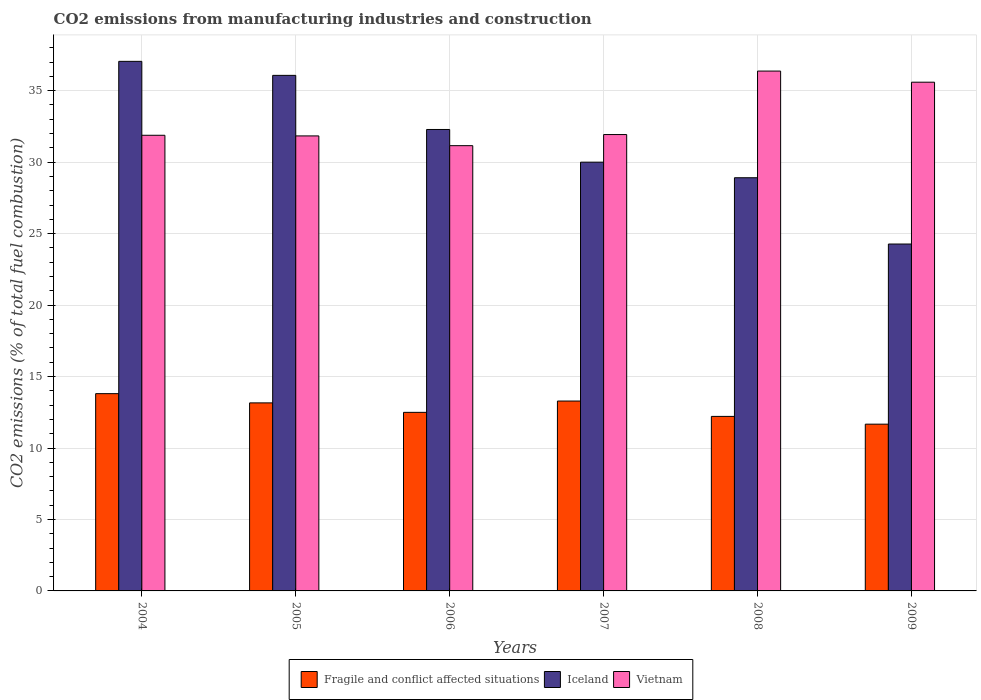Are the number of bars per tick equal to the number of legend labels?
Provide a succinct answer. Yes. Are the number of bars on each tick of the X-axis equal?
Provide a succinct answer. Yes. In how many cases, is the number of bars for a given year not equal to the number of legend labels?
Provide a succinct answer. 0. What is the amount of CO2 emitted in Iceland in 2008?
Your response must be concise. 28.91. Across all years, what is the maximum amount of CO2 emitted in Fragile and conflict affected situations?
Keep it short and to the point. 13.8. Across all years, what is the minimum amount of CO2 emitted in Fragile and conflict affected situations?
Offer a terse response. 11.67. What is the total amount of CO2 emitted in Vietnam in the graph?
Your answer should be very brief. 198.77. What is the difference between the amount of CO2 emitted in Vietnam in 2006 and that in 2008?
Offer a terse response. -5.22. What is the difference between the amount of CO2 emitted in Iceland in 2006 and the amount of CO2 emitted in Fragile and conflict affected situations in 2004?
Offer a terse response. 18.48. What is the average amount of CO2 emitted in Vietnam per year?
Your response must be concise. 33.13. In the year 2004, what is the difference between the amount of CO2 emitted in Iceland and amount of CO2 emitted in Fragile and conflict affected situations?
Give a very brief answer. 23.25. What is the ratio of the amount of CO2 emitted in Iceland in 2004 to that in 2007?
Provide a short and direct response. 1.24. Is the amount of CO2 emitted in Iceland in 2004 less than that in 2009?
Your answer should be compact. No. What is the difference between the highest and the second highest amount of CO2 emitted in Fragile and conflict affected situations?
Your response must be concise. 0.52. What is the difference between the highest and the lowest amount of CO2 emitted in Fragile and conflict affected situations?
Give a very brief answer. 2.13. In how many years, is the amount of CO2 emitted in Vietnam greater than the average amount of CO2 emitted in Vietnam taken over all years?
Keep it short and to the point. 2. What does the 3rd bar from the left in 2007 represents?
Your answer should be compact. Vietnam. What does the 3rd bar from the right in 2009 represents?
Ensure brevity in your answer.  Fragile and conflict affected situations. Is it the case that in every year, the sum of the amount of CO2 emitted in Vietnam and amount of CO2 emitted in Iceland is greater than the amount of CO2 emitted in Fragile and conflict affected situations?
Offer a terse response. Yes. Are the values on the major ticks of Y-axis written in scientific E-notation?
Your response must be concise. No. Does the graph contain any zero values?
Your answer should be compact. No. Does the graph contain grids?
Ensure brevity in your answer.  Yes. How many legend labels are there?
Your answer should be compact. 3. What is the title of the graph?
Your answer should be very brief. CO2 emissions from manufacturing industries and construction. Does "Kenya" appear as one of the legend labels in the graph?
Your answer should be very brief. No. What is the label or title of the Y-axis?
Your answer should be compact. CO2 emissions (% of total fuel combustion). What is the CO2 emissions (% of total fuel combustion) in Fragile and conflict affected situations in 2004?
Your answer should be very brief. 13.8. What is the CO2 emissions (% of total fuel combustion) in Iceland in 2004?
Your response must be concise. 37.05. What is the CO2 emissions (% of total fuel combustion) in Vietnam in 2004?
Make the answer very short. 31.88. What is the CO2 emissions (% of total fuel combustion) of Fragile and conflict affected situations in 2005?
Your answer should be compact. 13.16. What is the CO2 emissions (% of total fuel combustion) in Iceland in 2005?
Offer a very short reply. 36.07. What is the CO2 emissions (% of total fuel combustion) in Vietnam in 2005?
Provide a short and direct response. 31.84. What is the CO2 emissions (% of total fuel combustion) of Fragile and conflict affected situations in 2006?
Keep it short and to the point. 12.49. What is the CO2 emissions (% of total fuel combustion) in Iceland in 2006?
Make the answer very short. 32.29. What is the CO2 emissions (% of total fuel combustion) of Vietnam in 2006?
Offer a very short reply. 31.15. What is the CO2 emissions (% of total fuel combustion) in Fragile and conflict affected situations in 2007?
Offer a terse response. 13.29. What is the CO2 emissions (% of total fuel combustion) in Vietnam in 2007?
Offer a terse response. 31.93. What is the CO2 emissions (% of total fuel combustion) of Fragile and conflict affected situations in 2008?
Provide a short and direct response. 12.21. What is the CO2 emissions (% of total fuel combustion) of Iceland in 2008?
Keep it short and to the point. 28.91. What is the CO2 emissions (% of total fuel combustion) of Vietnam in 2008?
Ensure brevity in your answer.  36.37. What is the CO2 emissions (% of total fuel combustion) of Fragile and conflict affected situations in 2009?
Give a very brief answer. 11.67. What is the CO2 emissions (% of total fuel combustion) of Iceland in 2009?
Provide a short and direct response. 24.27. What is the CO2 emissions (% of total fuel combustion) of Vietnam in 2009?
Keep it short and to the point. 35.6. Across all years, what is the maximum CO2 emissions (% of total fuel combustion) of Fragile and conflict affected situations?
Your answer should be compact. 13.8. Across all years, what is the maximum CO2 emissions (% of total fuel combustion) of Iceland?
Ensure brevity in your answer.  37.05. Across all years, what is the maximum CO2 emissions (% of total fuel combustion) in Vietnam?
Offer a terse response. 36.37. Across all years, what is the minimum CO2 emissions (% of total fuel combustion) in Fragile and conflict affected situations?
Offer a very short reply. 11.67. Across all years, what is the minimum CO2 emissions (% of total fuel combustion) of Iceland?
Give a very brief answer. 24.27. Across all years, what is the minimum CO2 emissions (% of total fuel combustion) of Vietnam?
Ensure brevity in your answer.  31.15. What is the total CO2 emissions (% of total fuel combustion) in Fragile and conflict affected situations in the graph?
Provide a short and direct response. 76.62. What is the total CO2 emissions (% of total fuel combustion) of Iceland in the graph?
Keep it short and to the point. 188.6. What is the total CO2 emissions (% of total fuel combustion) of Vietnam in the graph?
Your response must be concise. 198.77. What is the difference between the CO2 emissions (% of total fuel combustion) in Fragile and conflict affected situations in 2004 and that in 2005?
Your answer should be compact. 0.65. What is the difference between the CO2 emissions (% of total fuel combustion) in Iceland in 2004 and that in 2005?
Offer a very short reply. 0.98. What is the difference between the CO2 emissions (% of total fuel combustion) in Vietnam in 2004 and that in 2005?
Ensure brevity in your answer.  0.04. What is the difference between the CO2 emissions (% of total fuel combustion) of Fragile and conflict affected situations in 2004 and that in 2006?
Keep it short and to the point. 1.31. What is the difference between the CO2 emissions (% of total fuel combustion) in Iceland in 2004 and that in 2006?
Ensure brevity in your answer.  4.77. What is the difference between the CO2 emissions (% of total fuel combustion) in Vietnam in 2004 and that in 2006?
Ensure brevity in your answer.  0.73. What is the difference between the CO2 emissions (% of total fuel combustion) of Fragile and conflict affected situations in 2004 and that in 2007?
Your answer should be very brief. 0.52. What is the difference between the CO2 emissions (% of total fuel combustion) of Iceland in 2004 and that in 2007?
Your response must be concise. 7.05. What is the difference between the CO2 emissions (% of total fuel combustion) of Vietnam in 2004 and that in 2007?
Keep it short and to the point. -0.05. What is the difference between the CO2 emissions (% of total fuel combustion) in Fragile and conflict affected situations in 2004 and that in 2008?
Offer a terse response. 1.59. What is the difference between the CO2 emissions (% of total fuel combustion) in Iceland in 2004 and that in 2008?
Your response must be concise. 8.14. What is the difference between the CO2 emissions (% of total fuel combustion) in Vietnam in 2004 and that in 2008?
Give a very brief answer. -4.49. What is the difference between the CO2 emissions (% of total fuel combustion) of Fragile and conflict affected situations in 2004 and that in 2009?
Keep it short and to the point. 2.13. What is the difference between the CO2 emissions (% of total fuel combustion) in Iceland in 2004 and that in 2009?
Your response must be concise. 12.78. What is the difference between the CO2 emissions (% of total fuel combustion) of Vietnam in 2004 and that in 2009?
Provide a short and direct response. -3.71. What is the difference between the CO2 emissions (% of total fuel combustion) in Fragile and conflict affected situations in 2005 and that in 2006?
Your answer should be very brief. 0.66. What is the difference between the CO2 emissions (% of total fuel combustion) of Iceland in 2005 and that in 2006?
Offer a very short reply. 3.79. What is the difference between the CO2 emissions (% of total fuel combustion) of Vietnam in 2005 and that in 2006?
Ensure brevity in your answer.  0.68. What is the difference between the CO2 emissions (% of total fuel combustion) in Fragile and conflict affected situations in 2005 and that in 2007?
Your answer should be compact. -0.13. What is the difference between the CO2 emissions (% of total fuel combustion) of Iceland in 2005 and that in 2007?
Your answer should be very brief. 6.07. What is the difference between the CO2 emissions (% of total fuel combustion) in Vietnam in 2005 and that in 2007?
Ensure brevity in your answer.  -0.09. What is the difference between the CO2 emissions (% of total fuel combustion) of Fragile and conflict affected situations in 2005 and that in 2008?
Provide a short and direct response. 0.95. What is the difference between the CO2 emissions (% of total fuel combustion) in Iceland in 2005 and that in 2008?
Your response must be concise. 7.16. What is the difference between the CO2 emissions (% of total fuel combustion) in Vietnam in 2005 and that in 2008?
Keep it short and to the point. -4.54. What is the difference between the CO2 emissions (% of total fuel combustion) of Fragile and conflict affected situations in 2005 and that in 2009?
Your answer should be very brief. 1.49. What is the difference between the CO2 emissions (% of total fuel combustion) in Iceland in 2005 and that in 2009?
Keep it short and to the point. 11.8. What is the difference between the CO2 emissions (% of total fuel combustion) of Vietnam in 2005 and that in 2009?
Provide a short and direct response. -3.76. What is the difference between the CO2 emissions (% of total fuel combustion) of Fragile and conflict affected situations in 2006 and that in 2007?
Your response must be concise. -0.79. What is the difference between the CO2 emissions (% of total fuel combustion) in Iceland in 2006 and that in 2007?
Keep it short and to the point. 2.29. What is the difference between the CO2 emissions (% of total fuel combustion) of Vietnam in 2006 and that in 2007?
Ensure brevity in your answer.  -0.78. What is the difference between the CO2 emissions (% of total fuel combustion) in Fragile and conflict affected situations in 2006 and that in 2008?
Provide a short and direct response. 0.28. What is the difference between the CO2 emissions (% of total fuel combustion) of Iceland in 2006 and that in 2008?
Provide a short and direct response. 3.38. What is the difference between the CO2 emissions (% of total fuel combustion) of Vietnam in 2006 and that in 2008?
Offer a very short reply. -5.22. What is the difference between the CO2 emissions (% of total fuel combustion) in Fragile and conflict affected situations in 2006 and that in 2009?
Make the answer very short. 0.83. What is the difference between the CO2 emissions (% of total fuel combustion) in Iceland in 2006 and that in 2009?
Give a very brief answer. 8.02. What is the difference between the CO2 emissions (% of total fuel combustion) of Vietnam in 2006 and that in 2009?
Ensure brevity in your answer.  -4.44. What is the difference between the CO2 emissions (% of total fuel combustion) in Fragile and conflict affected situations in 2007 and that in 2008?
Provide a short and direct response. 1.07. What is the difference between the CO2 emissions (% of total fuel combustion) of Iceland in 2007 and that in 2008?
Provide a succinct answer. 1.09. What is the difference between the CO2 emissions (% of total fuel combustion) of Vietnam in 2007 and that in 2008?
Give a very brief answer. -4.44. What is the difference between the CO2 emissions (% of total fuel combustion) in Fragile and conflict affected situations in 2007 and that in 2009?
Your answer should be very brief. 1.62. What is the difference between the CO2 emissions (% of total fuel combustion) of Iceland in 2007 and that in 2009?
Provide a short and direct response. 5.73. What is the difference between the CO2 emissions (% of total fuel combustion) of Vietnam in 2007 and that in 2009?
Your answer should be compact. -3.66. What is the difference between the CO2 emissions (% of total fuel combustion) of Fragile and conflict affected situations in 2008 and that in 2009?
Offer a very short reply. 0.54. What is the difference between the CO2 emissions (% of total fuel combustion) of Iceland in 2008 and that in 2009?
Provide a short and direct response. 4.64. What is the difference between the CO2 emissions (% of total fuel combustion) of Vietnam in 2008 and that in 2009?
Provide a short and direct response. 0.78. What is the difference between the CO2 emissions (% of total fuel combustion) of Fragile and conflict affected situations in 2004 and the CO2 emissions (% of total fuel combustion) of Iceland in 2005?
Your answer should be very brief. -22.27. What is the difference between the CO2 emissions (% of total fuel combustion) in Fragile and conflict affected situations in 2004 and the CO2 emissions (% of total fuel combustion) in Vietnam in 2005?
Your answer should be very brief. -18.03. What is the difference between the CO2 emissions (% of total fuel combustion) of Iceland in 2004 and the CO2 emissions (% of total fuel combustion) of Vietnam in 2005?
Ensure brevity in your answer.  5.22. What is the difference between the CO2 emissions (% of total fuel combustion) of Fragile and conflict affected situations in 2004 and the CO2 emissions (% of total fuel combustion) of Iceland in 2006?
Make the answer very short. -18.48. What is the difference between the CO2 emissions (% of total fuel combustion) of Fragile and conflict affected situations in 2004 and the CO2 emissions (% of total fuel combustion) of Vietnam in 2006?
Give a very brief answer. -17.35. What is the difference between the CO2 emissions (% of total fuel combustion) in Iceland in 2004 and the CO2 emissions (% of total fuel combustion) in Vietnam in 2006?
Your response must be concise. 5.9. What is the difference between the CO2 emissions (% of total fuel combustion) in Fragile and conflict affected situations in 2004 and the CO2 emissions (% of total fuel combustion) in Iceland in 2007?
Your answer should be very brief. -16.2. What is the difference between the CO2 emissions (% of total fuel combustion) of Fragile and conflict affected situations in 2004 and the CO2 emissions (% of total fuel combustion) of Vietnam in 2007?
Offer a very short reply. -18.13. What is the difference between the CO2 emissions (% of total fuel combustion) of Iceland in 2004 and the CO2 emissions (% of total fuel combustion) of Vietnam in 2007?
Give a very brief answer. 5.12. What is the difference between the CO2 emissions (% of total fuel combustion) in Fragile and conflict affected situations in 2004 and the CO2 emissions (% of total fuel combustion) in Iceland in 2008?
Your answer should be very brief. -15.11. What is the difference between the CO2 emissions (% of total fuel combustion) in Fragile and conflict affected situations in 2004 and the CO2 emissions (% of total fuel combustion) in Vietnam in 2008?
Your response must be concise. -22.57. What is the difference between the CO2 emissions (% of total fuel combustion) in Iceland in 2004 and the CO2 emissions (% of total fuel combustion) in Vietnam in 2008?
Your response must be concise. 0.68. What is the difference between the CO2 emissions (% of total fuel combustion) of Fragile and conflict affected situations in 2004 and the CO2 emissions (% of total fuel combustion) of Iceland in 2009?
Ensure brevity in your answer.  -10.47. What is the difference between the CO2 emissions (% of total fuel combustion) in Fragile and conflict affected situations in 2004 and the CO2 emissions (% of total fuel combustion) in Vietnam in 2009?
Provide a short and direct response. -21.79. What is the difference between the CO2 emissions (% of total fuel combustion) of Iceland in 2004 and the CO2 emissions (% of total fuel combustion) of Vietnam in 2009?
Provide a succinct answer. 1.46. What is the difference between the CO2 emissions (% of total fuel combustion) of Fragile and conflict affected situations in 2005 and the CO2 emissions (% of total fuel combustion) of Iceland in 2006?
Provide a succinct answer. -19.13. What is the difference between the CO2 emissions (% of total fuel combustion) of Fragile and conflict affected situations in 2005 and the CO2 emissions (% of total fuel combustion) of Vietnam in 2006?
Provide a succinct answer. -18. What is the difference between the CO2 emissions (% of total fuel combustion) of Iceland in 2005 and the CO2 emissions (% of total fuel combustion) of Vietnam in 2006?
Your answer should be very brief. 4.92. What is the difference between the CO2 emissions (% of total fuel combustion) of Fragile and conflict affected situations in 2005 and the CO2 emissions (% of total fuel combustion) of Iceland in 2007?
Ensure brevity in your answer.  -16.84. What is the difference between the CO2 emissions (% of total fuel combustion) in Fragile and conflict affected situations in 2005 and the CO2 emissions (% of total fuel combustion) in Vietnam in 2007?
Offer a very short reply. -18.77. What is the difference between the CO2 emissions (% of total fuel combustion) of Iceland in 2005 and the CO2 emissions (% of total fuel combustion) of Vietnam in 2007?
Your answer should be compact. 4.14. What is the difference between the CO2 emissions (% of total fuel combustion) in Fragile and conflict affected situations in 2005 and the CO2 emissions (% of total fuel combustion) in Iceland in 2008?
Provide a short and direct response. -15.75. What is the difference between the CO2 emissions (% of total fuel combustion) of Fragile and conflict affected situations in 2005 and the CO2 emissions (% of total fuel combustion) of Vietnam in 2008?
Make the answer very short. -23.22. What is the difference between the CO2 emissions (% of total fuel combustion) in Iceland in 2005 and the CO2 emissions (% of total fuel combustion) in Vietnam in 2008?
Ensure brevity in your answer.  -0.3. What is the difference between the CO2 emissions (% of total fuel combustion) in Fragile and conflict affected situations in 2005 and the CO2 emissions (% of total fuel combustion) in Iceland in 2009?
Give a very brief answer. -11.11. What is the difference between the CO2 emissions (% of total fuel combustion) in Fragile and conflict affected situations in 2005 and the CO2 emissions (% of total fuel combustion) in Vietnam in 2009?
Your answer should be compact. -22.44. What is the difference between the CO2 emissions (% of total fuel combustion) of Iceland in 2005 and the CO2 emissions (% of total fuel combustion) of Vietnam in 2009?
Provide a short and direct response. 0.48. What is the difference between the CO2 emissions (% of total fuel combustion) of Fragile and conflict affected situations in 2006 and the CO2 emissions (% of total fuel combustion) of Iceland in 2007?
Give a very brief answer. -17.51. What is the difference between the CO2 emissions (% of total fuel combustion) in Fragile and conflict affected situations in 2006 and the CO2 emissions (% of total fuel combustion) in Vietnam in 2007?
Ensure brevity in your answer.  -19.44. What is the difference between the CO2 emissions (% of total fuel combustion) in Iceland in 2006 and the CO2 emissions (% of total fuel combustion) in Vietnam in 2007?
Your response must be concise. 0.36. What is the difference between the CO2 emissions (% of total fuel combustion) in Fragile and conflict affected situations in 2006 and the CO2 emissions (% of total fuel combustion) in Iceland in 2008?
Keep it short and to the point. -16.42. What is the difference between the CO2 emissions (% of total fuel combustion) of Fragile and conflict affected situations in 2006 and the CO2 emissions (% of total fuel combustion) of Vietnam in 2008?
Your answer should be very brief. -23.88. What is the difference between the CO2 emissions (% of total fuel combustion) of Iceland in 2006 and the CO2 emissions (% of total fuel combustion) of Vietnam in 2008?
Give a very brief answer. -4.09. What is the difference between the CO2 emissions (% of total fuel combustion) in Fragile and conflict affected situations in 2006 and the CO2 emissions (% of total fuel combustion) in Iceland in 2009?
Provide a short and direct response. -11.78. What is the difference between the CO2 emissions (% of total fuel combustion) in Fragile and conflict affected situations in 2006 and the CO2 emissions (% of total fuel combustion) in Vietnam in 2009?
Your response must be concise. -23.1. What is the difference between the CO2 emissions (% of total fuel combustion) of Iceland in 2006 and the CO2 emissions (% of total fuel combustion) of Vietnam in 2009?
Offer a very short reply. -3.31. What is the difference between the CO2 emissions (% of total fuel combustion) in Fragile and conflict affected situations in 2007 and the CO2 emissions (% of total fuel combustion) in Iceland in 2008?
Your answer should be compact. -15.62. What is the difference between the CO2 emissions (% of total fuel combustion) in Fragile and conflict affected situations in 2007 and the CO2 emissions (% of total fuel combustion) in Vietnam in 2008?
Offer a terse response. -23.09. What is the difference between the CO2 emissions (% of total fuel combustion) in Iceland in 2007 and the CO2 emissions (% of total fuel combustion) in Vietnam in 2008?
Provide a succinct answer. -6.37. What is the difference between the CO2 emissions (% of total fuel combustion) in Fragile and conflict affected situations in 2007 and the CO2 emissions (% of total fuel combustion) in Iceland in 2009?
Your answer should be very brief. -10.99. What is the difference between the CO2 emissions (% of total fuel combustion) of Fragile and conflict affected situations in 2007 and the CO2 emissions (% of total fuel combustion) of Vietnam in 2009?
Provide a succinct answer. -22.31. What is the difference between the CO2 emissions (% of total fuel combustion) in Iceland in 2007 and the CO2 emissions (% of total fuel combustion) in Vietnam in 2009?
Ensure brevity in your answer.  -5.59. What is the difference between the CO2 emissions (% of total fuel combustion) of Fragile and conflict affected situations in 2008 and the CO2 emissions (% of total fuel combustion) of Iceland in 2009?
Give a very brief answer. -12.06. What is the difference between the CO2 emissions (% of total fuel combustion) of Fragile and conflict affected situations in 2008 and the CO2 emissions (% of total fuel combustion) of Vietnam in 2009?
Make the answer very short. -23.38. What is the difference between the CO2 emissions (% of total fuel combustion) in Iceland in 2008 and the CO2 emissions (% of total fuel combustion) in Vietnam in 2009?
Keep it short and to the point. -6.69. What is the average CO2 emissions (% of total fuel combustion) of Fragile and conflict affected situations per year?
Keep it short and to the point. 12.77. What is the average CO2 emissions (% of total fuel combustion) of Iceland per year?
Your response must be concise. 31.43. What is the average CO2 emissions (% of total fuel combustion) in Vietnam per year?
Ensure brevity in your answer.  33.13. In the year 2004, what is the difference between the CO2 emissions (% of total fuel combustion) in Fragile and conflict affected situations and CO2 emissions (% of total fuel combustion) in Iceland?
Provide a succinct answer. -23.25. In the year 2004, what is the difference between the CO2 emissions (% of total fuel combustion) in Fragile and conflict affected situations and CO2 emissions (% of total fuel combustion) in Vietnam?
Make the answer very short. -18.08. In the year 2004, what is the difference between the CO2 emissions (% of total fuel combustion) of Iceland and CO2 emissions (% of total fuel combustion) of Vietnam?
Make the answer very short. 5.17. In the year 2005, what is the difference between the CO2 emissions (% of total fuel combustion) of Fragile and conflict affected situations and CO2 emissions (% of total fuel combustion) of Iceland?
Keep it short and to the point. -22.92. In the year 2005, what is the difference between the CO2 emissions (% of total fuel combustion) of Fragile and conflict affected situations and CO2 emissions (% of total fuel combustion) of Vietnam?
Offer a terse response. -18.68. In the year 2005, what is the difference between the CO2 emissions (% of total fuel combustion) of Iceland and CO2 emissions (% of total fuel combustion) of Vietnam?
Make the answer very short. 4.24. In the year 2006, what is the difference between the CO2 emissions (% of total fuel combustion) in Fragile and conflict affected situations and CO2 emissions (% of total fuel combustion) in Iceland?
Make the answer very short. -19.79. In the year 2006, what is the difference between the CO2 emissions (% of total fuel combustion) of Fragile and conflict affected situations and CO2 emissions (% of total fuel combustion) of Vietnam?
Provide a succinct answer. -18.66. In the year 2006, what is the difference between the CO2 emissions (% of total fuel combustion) in Iceland and CO2 emissions (% of total fuel combustion) in Vietnam?
Ensure brevity in your answer.  1.13. In the year 2007, what is the difference between the CO2 emissions (% of total fuel combustion) of Fragile and conflict affected situations and CO2 emissions (% of total fuel combustion) of Iceland?
Offer a very short reply. -16.71. In the year 2007, what is the difference between the CO2 emissions (% of total fuel combustion) of Fragile and conflict affected situations and CO2 emissions (% of total fuel combustion) of Vietnam?
Provide a short and direct response. -18.65. In the year 2007, what is the difference between the CO2 emissions (% of total fuel combustion) in Iceland and CO2 emissions (% of total fuel combustion) in Vietnam?
Offer a terse response. -1.93. In the year 2008, what is the difference between the CO2 emissions (% of total fuel combustion) of Fragile and conflict affected situations and CO2 emissions (% of total fuel combustion) of Iceland?
Your response must be concise. -16.7. In the year 2008, what is the difference between the CO2 emissions (% of total fuel combustion) of Fragile and conflict affected situations and CO2 emissions (% of total fuel combustion) of Vietnam?
Provide a succinct answer. -24.16. In the year 2008, what is the difference between the CO2 emissions (% of total fuel combustion) in Iceland and CO2 emissions (% of total fuel combustion) in Vietnam?
Your response must be concise. -7.46. In the year 2009, what is the difference between the CO2 emissions (% of total fuel combustion) of Fragile and conflict affected situations and CO2 emissions (% of total fuel combustion) of Iceland?
Offer a terse response. -12.6. In the year 2009, what is the difference between the CO2 emissions (% of total fuel combustion) of Fragile and conflict affected situations and CO2 emissions (% of total fuel combustion) of Vietnam?
Offer a terse response. -23.93. In the year 2009, what is the difference between the CO2 emissions (% of total fuel combustion) in Iceland and CO2 emissions (% of total fuel combustion) in Vietnam?
Keep it short and to the point. -11.32. What is the ratio of the CO2 emissions (% of total fuel combustion) in Fragile and conflict affected situations in 2004 to that in 2005?
Make the answer very short. 1.05. What is the ratio of the CO2 emissions (% of total fuel combustion) in Iceland in 2004 to that in 2005?
Offer a very short reply. 1.03. What is the ratio of the CO2 emissions (% of total fuel combustion) of Fragile and conflict affected situations in 2004 to that in 2006?
Provide a succinct answer. 1.1. What is the ratio of the CO2 emissions (% of total fuel combustion) of Iceland in 2004 to that in 2006?
Your response must be concise. 1.15. What is the ratio of the CO2 emissions (% of total fuel combustion) in Vietnam in 2004 to that in 2006?
Make the answer very short. 1.02. What is the ratio of the CO2 emissions (% of total fuel combustion) in Fragile and conflict affected situations in 2004 to that in 2007?
Offer a terse response. 1.04. What is the ratio of the CO2 emissions (% of total fuel combustion) of Iceland in 2004 to that in 2007?
Offer a very short reply. 1.24. What is the ratio of the CO2 emissions (% of total fuel combustion) of Fragile and conflict affected situations in 2004 to that in 2008?
Your response must be concise. 1.13. What is the ratio of the CO2 emissions (% of total fuel combustion) in Iceland in 2004 to that in 2008?
Make the answer very short. 1.28. What is the ratio of the CO2 emissions (% of total fuel combustion) of Vietnam in 2004 to that in 2008?
Keep it short and to the point. 0.88. What is the ratio of the CO2 emissions (% of total fuel combustion) in Fragile and conflict affected situations in 2004 to that in 2009?
Make the answer very short. 1.18. What is the ratio of the CO2 emissions (% of total fuel combustion) of Iceland in 2004 to that in 2009?
Keep it short and to the point. 1.53. What is the ratio of the CO2 emissions (% of total fuel combustion) of Vietnam in 2004 to that in 2009?
Your answer should be compact. 0.9. What is the ratio of the CO2 emissions (% of total fuel combustion) in Fragile and conflict affected situations in 2005 to that in 2006?
Keep it short and to the point. 1.05. What is the ratio of the CO2 emissions (% of total fuel combustion) in Iceland in 2005 to that in 2006?
Offer a terse response. 1.12. What is the ratio of the CO2 emissions (% of total fuel combustion) in Vietnam in 2005 to that in 2006?
Keep it short and to the point. 1.02. What is the ratio of the CO2 emissions (% of total fuel combustion) of Fragile and conflict affected situations in 2005 to that in 2007?
Keep it short and to the point. 0.99. What is the ratio of the CO2 emissions (% of total fuel combustion) of Iceland in 2005 to that in 2007?
Your answer should be very brief. 1.2. What is the ratio of the CO2 emissions (% of total fuel combustion) of Vietnam in 2005 to that in 2007?
Your response must be concise. 1. What is the ratio of the CO2 emissions (% of total fuel combustion) in Fragile and conflict affected situations in 2005 to that in 2008?
Offer a terse response. 1.08. What is the ratio of the CO2 emissions (% of total fuel combustion) of Iceland in 2005 to that in 2008?
Keep it short and to the point. 1.25. What is the ratio of the CO2 emissions (% of total fuel combustion) in Vietnam in 2005 to that in 2008?
Keep it short and to the point. 0.88. What is the ratio of the CO2 emissions (% of total fuel combustion) in Fragile and conflict affected situations in 2005 to that in 2009?
Provide a short and direct response. 1.13. What is the ratio of the CO2 emissions (% of total fuel combustion) in Iceland in 2005 to that in 2009?
Your answer should be compact. 1.49. What is the ratio of the CO2 emissions (% of total fuel combustion) in Vietnam in 2005 to that in 2009?
Make the answer very short. 0.89. What is the ratio of the CO2 emissions (% of total fuel combustion) in Fragile and conflict affected situations in 2006 to that in 2007?
Make the answer very short. 0.94. What is the ratio of the CO2 emissions (% of total fuel combustion) of Iceland in 2006 to that in 2007?
Your response must be concise. 1.08. What is the ratio of the CO2 emissions (% of total fuel combustion) in Vietnam in 2006 to that in 2007?
Offer a terse response. 0.98. What is the ratio of the CO2 emissions (% of total fuel combustion) of Fragile and conflict affected situations in 2006 to that in 2008?
Keep it short and to the point. 1.02. What is the ratio of the CO2 emissions (% of total fuel combustion) of Iceland in 2006 to that in 2008?
Offer a terse response. 1.12. What is the ratio of the CO2 emissions (% of total fuel combustion) in Vietnam in 2006 to that in 2008?
Provide a succinct answer. 0.86. What is the ratio of the CO2 emissions (% of total fuel combustion) of Fragile and conflict affected situations in 2006 to that in 2009?
Make the answer very short. 1.07. What is the ratio of the CO2 emissions (% of total fuel combustion) in Iceland in 2006 to that in 2009?
Your response must be concise. 1.33. What is the ratio of the CO2 emissions (% of total fuel combustion) of Vietnam in 2006 to that in 2009?
Make the answer very short. 0.88. What is the ratio of the CO2 emissions (% of total fuel combustion) in Fragile and conflict affected situations in 2007 to that in 2008?
Make the answer very short. 1.09. What is the ratio of the CO2 emissions (% of total fuel combustion) in Iceland in 2007 to that in 2008?
Provide a succinct answer. 1.04. What is the ratio of the CO2 emissions (% of total fuel combustion) of Vietnam in 2007 to that in 2008?
Keep it short and to the point. 0.88. What is the ratio of the CO2 emissions (% of total fuel combustion) of Fragile and conflict affected situations in 2007 to that in 2009?
Provide a short and direct response. 1.14. What is the ratio of the CO2 emissions (% of total fuel combustion) in Iceland in 2007 to that in 2009?
Your answer should be very brief. 1.24. What is the ratio of the CO2 emissions (% of total fuel combustion) of Vietnam in 2007 to that in 2009?
Provide a short and direct response. 0.9. What is the ratio of the CO2 emissions (% of total fuel combustion) of Fragile and conflict affected situations in 2008 to that in 2009?
Keep it short and to the point. 1.05. What is the ratio of the CO2 emissions (% of total fuel combustion) in Iceland in 2008 to that in 2009?
Offer a very short reply. 1.19. What is the ratio of the CO2 emissions (% of total fuel combustion) in Vietnam in 2008 to that in 2009?
Offer a terse response. 1.02. What is the difference between the highest and the second highest CO2 emissions (% of total fuel combustion) of Fragile and conflict affected situations?
Make the answer very short. 0.52. What is the difference between the highest and the second highest CO2 emissions (% of total fuel combustion) of Iceland?
Provide a short and direct response. 0.98. What is the difference between the highest and the second highest CO2 emissions (% of total fuel combustion) of Vietnam?
Provide a short and direct response. 0.78. What is the difference between the highest and the lowest CO2 emissions (% of total fuel combustion) in Fragile and conflict affected situations?
Ensure brevity in your answer.  2.13. What is the difference between the highest and the lowest CO2 emissions (% of total fuel combustion) in Iceland?
Give a very brief answer. 12.78. What is the difference between the highest and the lowest CO2 emissions (% of total fuel combustion) in Vietnam?
Ensure brevity in your answer.  5.22. 